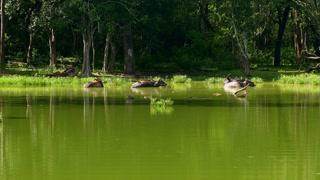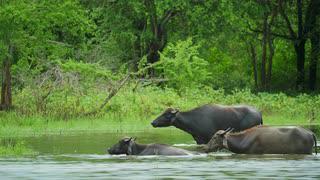The first image is the image on the left, the second image is the image on the right. Analyze the images presented: Is the assertion "The left and right image contains the same number black bulls." valid? Answer yes or no. Yes. The first image is the image on the left, the second image is the image on the right. For the images shown, is this caption "The right image features at least one leftward-headed water buffalo standing in profile in water that reaches its belly." true? Answer yes or no. Yes. 